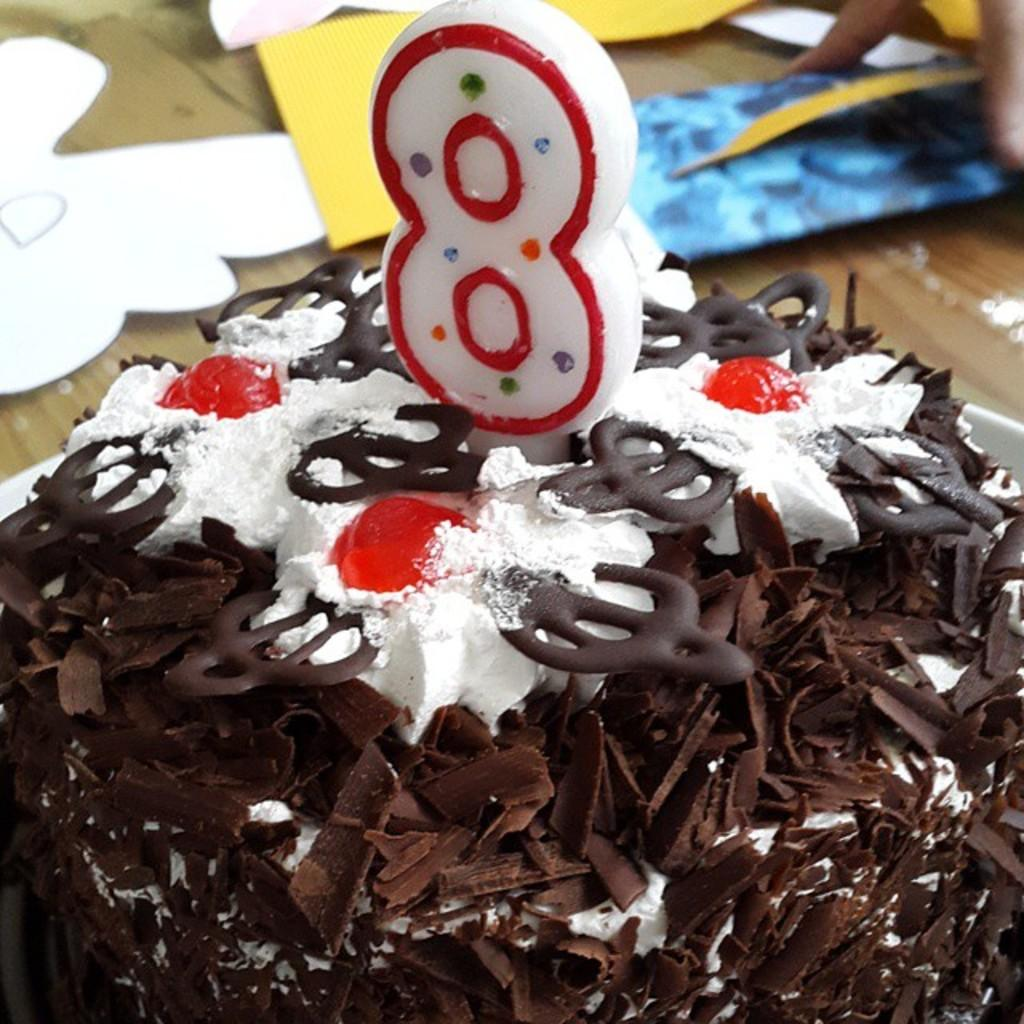What is the main object on the table in the image? There is a cake on a table in the image. Can you describe anything else in the image besides the cake? Yes, there is a person's hand visible in the background of the image. What type of trucks can be seen in the image? There are no trucks present in the image. How does the cake sense the presence of the person's hand in the image? The cake does not have the ability to sense anything, as it is an inanimate object. 